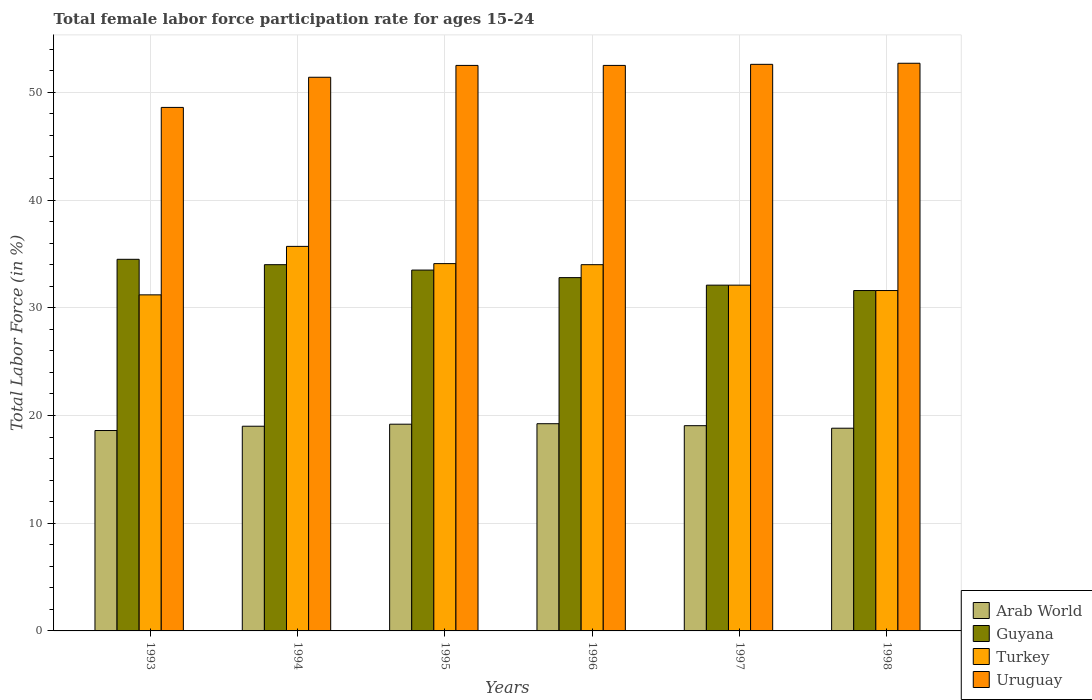Are the number of bars on each tick of the X-axis equal?
Provide a short and direct response. Yes. How many bars are there on the 2nd tick from the right?
Your response must be concise. 4. In how many cases, is the number of bars for a given year not equal to the number of legend labels?
Your response must be concise. 0. What is the female labor force participation rate in Uruguay in 1995?
Your answer should be compact. 52.5. Across all years, what is the maximum female labor force participation rate in Guyana?
Provide a succinct answer. 34.5. Across all years, what is the minimum female labor force participation rate in Arab World?
Keep it short and to the point. 18.6. In which year was the female labor force participation rate in Turkey maximum?
Give a very brief answer. 1994. What is the total female labor force participation rate in Arab World in the graph?
Ensure brevity in your answer.  113.91. What is the difference between the female labor force participation rate in Turkey in 1994 and that in 1998?
Ensure brevity in your answer.  4.1. What is the difference between the female labor force participation rate in Arab World in 1998 and the female labor force participation rate in Guyana in 1996?
Offer a terse response. -13.98. What is the average female labor force participation rate in Uruguay per year?
Your answer should be very brief. 51.72. In the year 1998, what is the difference between the female labor force participation rate in Arab World and female labor force participation rate in Turkey?
Offer a terse response. -12.78. What is the ratio of the female labor force participation rate in Guyana in 1995 to that in 1996?
Provide a succinct answer. 1.02. Is the difference between the female labor force participation rate in Arab World in 1993 and 1995 greater than the difference between the female labor force participation rate in Turkey in 1993 and 1995?
Your answer should be very brief. Yes. What is the difference between the highest and the second highest female labor force participation rate in Arab World?
Provide a short and direct response. 0.05. What is the difference between the highest and the lowest female labor force participation rate in Guyana?
Ensure brevity in your answer.  2.9. In how many years, is the female labor force participation rate in Uruguay greater than the average female labor force participation rate in Uruguay taken over all years?
Your response must be concise. 4. Is it the case that in every year, the sum of the female labor force participation rate in Turkey and female labor force participation rate in Uruguay is greater than the sum of female labor force participation rate in Guyana and female labor force participation rate in Arab World?
Provide a succinct answer. Yes. What does the 3rd bar from the left in 1995 represents?
Your response must be concise. Turkey. What does the 4th bar from the right in 1997 represents?
Your answer should be very brief. Arab World. What is the difference between two consecutive major ticks on the Y-axis?
Give a very brief answer. 10. Does the graph contain any zero values?
Ensure brevity in your answer.  No. Does the graph contain grids?
Provide a succinct answer. Yes. Where does the legend appear in the graph?
Ensure brevity in your answer.  Bottom right. How many legend labels are there?
Make the answer very short. 4. How are the legend labels stacked?
Give a very brief answer. Vertical. What is the title of the graph?
Keep it short and to the point. Total female labor force participation rate for ages 15-24. Does "Sudan" appear as one of the legend labels in the graph?
Ensure brevity in your answer.  No. What is the label or title of the X-axis?
Provide a short and direct response. Years. What is the label or title of the Y-axis?
Your answer should be compact. Total Labor Force (in %). What is the Total Labor Force (in %) in Arab World in 1993?
Your answer should be very brief. 18.6. What is the Total Labor Force (in %) of Guyana in 1993?
Make the answer very short. 34.5. What is the Total Labor Force (in %) of Turkey in 1993?
Give a very brief answer. 31.2. What is the Total Labor Force (in %) of Uruguay in 1993?
Your answer should be very brief. 48.6. What is the Total Labor Force (in %) in Arab World in 1994?
Your response must be concise. 19. What is the Total Labor Force (in %) of Turkey in 1994?
Your response must be concise. 35.7. What is the Total Labor Force (in %) in Uruguay in 1994?
Provide a short and direct response. 51.4. What is the Total Labor Force (in %) in Arab World in 1995?
Your answer should be compact. 19.19. What is the Total Labor Force (in %) of Guyana in 1995?
Provide a succinct answer. 33.5. What is the Total Labor Force (in %) in Turkey in 1995?
Offer a terse response. 34.1. What is the Total Labor Force (in %) of Uruguay in 1995?
Make the answer very short. 52.5. What is the Total Labor Force (in %) of Arab World in 1996?
Make the answer very short. 19.24. What is the Total Labor Force (in %) in Guyana in 1996?
Ensure brevity in your answer.  32.8. What is the Total Labor Force (in %) of Uruguay in 1996?
Your answer should be very brief. 52.5. What is the Total Labor Force (in %) of Arab World in 1997?
Make the answer very short. 19.05. What is the Total Labor Force (in %) of Guyana in 1997?
Give a very brief answer. 32.1. What is the Total Labor Force (in %) in Turkey in 1997?
Provide a succinct answer. 32.1. What is the Total Labor Force (in %) in Uruguay in 1997?
Your response must be concise. 52.6. What is the Total Labor Force (in %) in Arab World in 1998?
Provide a succinct answer. 18.82. What is the Total Labor Force (in %) of Guyana in 1998?
Give a very brief answer. 31.6. What is the Total Labor Force (in %) in Turkey in 1998?
Offer a very short reply. 31.6. What is the Total Labor Force (in %) of Uruguay in 1998?
Offer a very short reply. 52.7. Across all years, what is the maximum Total Labor Force (in %) of Arab World?
Your response must be concise. 19.24. Across all years, what is the maximum Total Labor Force (in %) in Guyana?
Your response must be concise. 34.5. Across all years, what is the maximum Total Labor Force (in %) in Turkey?
Keep it short and to the point. 35.7. Across all years, what is the maximum Total Labor Force (in %) in Uruguay?
Offer a very short reply. 52.7. Across all years, what is the minimum Total Labor Force (in %) in Arab World?
Make the answer very short. 18.6. Across all years, what is the minimum Total Labor Force (in %) of Guyana?
Keep it short and to the point. 31.6. Across all years, what is the minimum Total Labor Force (in %) of Turkey?
Your response must be concise. 31.2. Across all years, what is the minimum Total Labor Force (in %) in Uruguay?
Provide a short and direct response. 48.6. What is the total Total Labor Force (in %) in Arab World in the graph?
Make the answer very short. 113.91. What is the total Total Labor Force (in %) in Guyana in the graph?
Provide a short and direct response. 198.5. What is the total Total Labor Force (in %) in Turkey in the graph?
Give a very brief answer. 198.7. What is the total Total Labor Force (in %) in Uruguay in the graph?
Your response must be concise. 310.3. What is the difference between the Total Labor Force (in %) in Arab World in 1993 and that in 1994?
Offer a terse response. -0.4. What is the difference between the Total Labor Force (in %) in Uruguay in 1993 and that in 1994?
Keep it short and to the point. -2.8. What is the difference between the Total Labor Force (in %) of Arab World in 1993 and that in 1995?
Offer a very short reply. -0.59. What is the difference between the Total Labor Force (in %) in Guyana in 1993 and that in 1995?
Provide a succinct answer. 1. What is the difference between the Total Labor Force (in %) of Turkey in 1993 and that in 1995?
Make the answer very short. -2.9. What is the difference between the Total Labor Force (in %) of Arab World in 1993 and that in 1996?
Provide a short and direct response. -0.63. What is the difference between the Total Labor Force (in %) of Turkey in 1993 and that in 1996?
Ensure brevity in your answer.  -2.8. What is the difference between the Total Labor Force (in %) in Uruguay in 1993 and that in 1996?
Give a very brief answer. -3.9. What is the difference between the Total Labor Force (in %) of Arab World in 1993 and that in 1997?
Provide a short and direct response. -0.45. What is the difference between the Total Labor Force (in %) of Guyana in 1993 and that in 1997?
Make the answer very short. 2.4. What is the difference between the Total Labor Force (in %) in Uruguay in 1993 and that in 1997?
Offer a terse response. -4. What is the difference between the Total Labor Force (in %) in Arab World in 1993 and that in 1998?
Ensure brevity in your answer.  -0.22. What is the difference between the Total Labor Force (in %) of Guyana in 1993 and that in 1998?
Provide a short and direct response. 2.9. What is the difference between the Total Labor Force (in %) in Uruguay in 1993 and that in 1998?
Make the answer very short. -4.1. What is the difference between the Total Labor Force (in %) of Arab World in 1994 and that in 1995?
Offer a terse response. -0.19. What is the difference between the Total Labor Force (in %) in Uruguay in 1994 and that in 1995?
Offer a terse response. -1.1. What is the difference between the Total Labor Force (in %) in Arab World in 1994 and that in 1996?
Make the answer very short. -0.23. What is the difference between the Total Labor Force (in %) in Guyana in 1994 and that in 1996?
Keep it short and to the point. 1.2. What is the difference between the Total Labor Force (in %) in Turkey in 1994 and that in 1996?
Provide a succinct answer. 1.7. What is the difference between the Total Labor Force (in %) of Uruguay in 1994 and that in 1996?
Provide a short and direct response. -1.1. What is the difference between the Total Labor Force (in %) of Arab World in 1994 and that in 1997?
Give a very brief answer. -0.05. What is the difference between the Total Labor Force (in %) of Turkey in 1994 and that in 1997?
Your answer should be compact. 3.6. What is the difference between the Total Labor Force (in %) in Uruguay in 1994 and that in 1997?
Offer a very short reply. -1.2. What is the difference between the Total Labor Force (in %) of Arab World in 1994 and that in 1998?
Give a very brief answer. 0.18. What is the difference between the Total Labor Force (in %) in Guyana in 1994 and that in 1998?
Ensure brevity in your answer.  2.4. What is the difference between the Total Labor Force (in %) in Turkey in 1994 and that in 1998?
Your response must be concise. 4.1. What is the difference between the Total Labor Force (in %) in Arab World in 1995 and that in 1996?
Offer a terse response. -0.04. What is the difference between the Total Labor Force (in %) in Arab World in 1995 and that in 1997?
Give a very brief answer. 0.14. What is the difference between the Total Labor Force (in %) of Guyana in 1995 and that in 1997?
Your answer should be compact. 1.4. What is the difference between the Total Labor Force (in %) in Turkey in 1995 and that in 1997?
Your response must be concise. 2. What is the difference between the Total Labor Force (in %) of Uruguay in 1995 and that in 1997?
Your answer should be very brief. -0.1. What is the difference between the Total Labor Force (in %) of Arab World in 1995 and that in 1998?
Give a very brief answer. 0.37. What is the difference between the Total Labor Force (in %) of Arab World in 1996 and that in 1997?
Provide a short and direct response. 0.18. What is the difference between the Total Labor Force (in %) in Turkey in 1996 and that in 1997?
Your answer should be compact. 1.9. What is the difference between the Total Labor Force (in %) of Uruguay in 1996 and that in 1997?
Give a very brief answer. -0.1. What is the difference between the Total Labor Force (in %) of Arab World in 1996 and that in 1998?
Keep it short and to the point. 0.42. What is the difference between the Total Labor Force (in %) in Turkey in 1996 and that in 1998?
Offer a very short reply. 2.4. What is the difference between the Total Labor Force (in %) of Arab World in 1997 and that in 1998?
Your answer should be compact. 0.23. What is the difference between the Total Labor Force (in %) of Guyana in 1997 and that in 1998?
Keep it short and to the point. 0.5. What is the difference between the Total Labor Force (in %) of Turkey in 1997 and that in 1998?
Keep it short and to the point. 0.5. What is the difference between the Total Labor Force (in %) in Uruguay in 1997 and that in 1998?
Give a very brief answer. -0.1. What is the difference between the Total Labor Force (in %) of Arab World in 1993 and the Total Labor Force (in %) of Guyana in 1994?
Give a very brief answer. -15.4. What is the difference between the Total Labor Force (in %) in Arab World in 1993 and the Total Labor Force (in %) in Turkey in 1994?
Keep it short and to the point. -17.1. What is the difference between the Total Labor Force (in %) in Arab World in 1993 and the Total Labor Force (in %) in Uruguay in 1994?
Your response must be concise. -32.8. What is the difference between the Total Labor Force (in %) of Guyana in 1993 and the Total Labor Force (in %) of Turkey in 1994?
Provide a short and direct response. -1.2. What is the difference between the Total Labor Force (in %) in Guyana in 1993 and the Total Labor Force (in %) in Uruguay in 1994?
Ensure brevity in your answer.  -16.9. What is the difference between the Total Labor Force (in %) of Turkey in 1993 and the Total Labor Force (in %) of Uruguay in 1994?
Your answer should be compact. -20.2. What is the difference between the Total Labor Force (in %) in Arab World in 1993 and the Total Labor Force (in %) in Guyana in 1995?
Your answer should be compact. -14.9. What is the difference between the Total Labor Force (in %) of Arab World in 1993 and the Total Labor Force (in %) of Turkey in 1995?
Offer a terse response. -15.5. What is the difference between the Total Labor Force (in %) in Arab World in 1993 and the Total Labor Force (in %) in Uruguay in 1995?
Provide a short and direct response. -33.9. What is the difference between the Total Labor Force (in %) of Guyana in 1993 and the Total Labor Force (in %) of Turkey in 1995?
Keep it short and to the point. 0.4. What is the difference between the Total Labor Force (in %) in Guyana in 1993 and the Total Labor Force (in %) in Uruguay in 1995?
Make the answer very short. -18. What is the difference between the Total Labor Force (in %) of Turkey in 1993 and the Total Labor Force (in %) of Uruguay in 1995?
Make the answer very short. -21.3. What is the difference between the Total Labor Force (in %) of Arab World in 1993 and the Total Labor Force (in %) of Guyana in 1996?
Keep it short and to the point. -14.2. What is the difference between the Total Labor Force (in %) in Arab World in 1993 and the Total Labor Force (in %) in Turkey in 1996?
Make the answer very short. -15.4. What is the difference between the Total Labor Force (in %) in Arab World in 1993 and the Total Labor Force (in %) in Uruguay in 1996?
Provide a succinct answer. -33.9. What is the difference between the Total Labor Force (in %) in Guyana in 1993 and the Total Labor Force (in %) in Turkey in 1996?
Your answer should be very brief. 0.5. What is the difference between the Total Labor Force (in %) of Turkey in 1993 and the Total Labor Force (in %) of Uruguay in 1996?
Your answer should be very brief. -21.3. What is the difference between the Total Labor Force (in %) of Arab World in 1993 and the Total Labor Force (in %) of Guyana in 1997?
Provide a short and direct response. -13.5. What is the difference between the Total Labor Force (in %) of Arab World in 1993 and the Total Labor Force (in %) of Turkey in 1997?
Your answer should be very brief. -13.5. What is the difference between the Total Labor Force (in %) in Arab World in 1993 and the Total Labor Force (in %) in Uruguay in 1997?
Make the answer very short. -34. What is the difference between the Total Labor Force (in %) of Guyana in 1993 and the Total Labor Force (in %) of Uruguay in 1997?
Your answer should be compact. -18.1. What is the difference between the Total Labor Force (in %) in Turkey in 1993 and the Total Labor Force (in %) in Uruguay in 1997?
Provide a succinct answer. -21.4. What is the difference between the Total Labor Force (in %) of Arab World in 1993 and the Total Labor Force (in %) of Guyana in 1998?
Make the answer very short. -13. What is the difference between the Total Labor Force (in %) in Arab World in 1993 and the Total Labor Force (in %) in Turkey in 1998?
Offer a terse response. -13. What is the difference between the Total Labor Force (in %) in Arab World in 1993 and the Total Labor Force (in %) in Uruguay in 1998?
Provide a short and direct response. -34.1. What is the difference between the Total Labor Force (in %) of Guyana in 1993 and the Total Labor Force (in %) of Turkey in 1998?
Offer a terse response. 2.9. What is the difference between the Total Labor Force (in %) in Guyana in 1993 and the Total Labor Force (in %) in Uruguay in 1998?
Provide a short and direct response. -18.2. What is the difference between the Total Labor Force (in %) in Turkey in 1993 and the Total Labor Force (in %) in Uruguay in 1998?
Ensure brevity in your answer.  -21.5. What is the difference between the Total Labor Force (in %) of Arab World in 1994 and the Total Labor Force (in %) of Guyana in 1995?
Your response must be concise. -14.5. What is the difference between the Total Labor Force (in %) in Arab World in 1994 and the Total Labor Force (in %) in Turkey in 1995?
Your answer should be compact. -15.1. What is the difference between the Total Labor Force (in %) in Arab World in 1994 and the Total Labor Force (in %) in Uruguay in 1995?
Offer a terse response. -33.5. What is the difference between the Total Labor Force (in %) of Guyana in 1994 and the Total Labor Force (in %) of Turkey in 1995?
Keep it short and to the point. -0.1. What is the difference between the Total Labor Force (in %) of Guyana in 1994 and the Total Labor Force (in %) of Uruguay in 1995?
Offer a very short reply. -18.5. What is the difference between the Total Labor Force (in %) of Turkey in 1994 and the Total Labor Force (in %) of Uruguay in 1995?
Offer a terse response. -16.8. What is the difference between the Total Labor Force (in %) in Arab World in 1994 and the Total Labor Force (in %) in Guyana in 1996?
Give a very brief answer. -13.8. What is the difference between the Total Labor Force (in %) of Arab World in 1994 and the Total Labor Force (in %) of Turkey in 1996?
Offer a terse response. -15. What is the difference between the Total Labor Force (in %) in Arab World in 1994 and the Total Labor Force (in %) in Uruguay in 1996?
Provide a succinct answer. -33.5. What is the difference between the Total Labor Force (in %) in Guyana in 1994 and the Total Labor Force (in %) in Uruguay in 1996?
Your response must be concise. -18.5. What is the difference between the Total Labor Force (in %) in Turkey in 1994 and the Total Labor Force (in %) in Uruguay in 1996?
Offer a terse response. -16.8. What is the difference between the Total Labor Force (in %) of Arab World in 1994 and the Total Labor Force (in %) of Guyana in 1997?
Your response must be concise. -13.1. What is the difference between the Total Labor Force (in %) of Arab World in 1994 and the Total Labor Force (in %) of Turkey in 1997?
Keep it short and to the point. -13.1. What is the difference between the Total Labor Force (in %) in Arab World in 1994 and the Total Labor Force (in %) in Uruguay in 1997?
Offer a terse response. -33.6. What is the difference between the Total Labor Force (in %) of Guyana in 1994 and the Total Labor Force (in %) of Uruguay in 1997?
Keep it short and to the point. -18.6. What is the difference between the Total Labor Force (in %) in Turkey in 1994 and the Total Labor Force (in %) in Uruguay in 1997?
Give a very brief answer. -16.9. What is the difference between the Total Labor Force (in %) of Arab World in 1994 and the Total Labor Force (in %) of Guyana in 1998?
Offer a very short reply. -12.6. What is the difference between the Total Labor Force (in %) of Arab World in 1994 and the Total Labor Force (in %) of Turkey in 1998?
Your answer should be compact. -12.6. What is the difference between the Total Labor Force (in %) in Arab World in 1994 and the Total Labor Force (in %) in Uruguay in 1998?
Your answer should be very brief. -33.7. What is the difference between the Total Labor Force (in %) of Guyana in 1994 and the Total Labor Force (in %) of Turkey in 1998?
Your answer should be very brief. 2.4. What is the difference between the Total Labor Force (in %) in Guyana in 1994 and the Total Labor Force (in %) in Uruguay in 1998?
Provide a short and direct response. -18.7. What is the difference between the Total Labor Force (in %) in Turkey in 1994 and the Total Labor Force (in %) in Uruguay in 1998?
Your response must be concise. -17. What is the difference between the Total Labor Force (in %) of Arab World in 1995 and the Total Labor Force (in %) of Guyana in 1996?
Ensure brevity in your answer.  -13.61. What is the difference between the Total Labor Force (in %) in Arab World in 1995 and the Total Labor Force (in %) in Turkey in 1996?
Your answer should be compact. -14.81. What is the difference between the Total Labor Force (in %) of Arab World in 1995 and the Total Labor Force (in %) of Uruguay in 1996?
Your answer should be compact. -33.31. What is the difference between the Total Labor Force (in %) of Guyana in 1995 and the Total Labor Force (in %) of Turkey in 1996?
Give a very brief answer. -0.5. What is the difference between the Total Labor Force (in %) of Turkey in 1995 and the Total Labor Force (in %) of Uruguay in 1996?
Your response must be concise. -18.4. What is the difference between the Total Labor Force (in %) of Arab World in 1995 and the Total Labor Force (in %) of Guyana in 1997?
Give a very brief answer. -12.91. What is the difference between the Total Labor Force (in %) of Arab World in 1995 and the Total Labor Force (in %) of Turkey in 1997?
Offer a very short reply. -12.91. What is the difference between the Total Labor Force (in %) of Arab World in 1995 and the Total Labor Force (in %) of Uruguay in 1997?
Provide a succinct answer. -33.41. What is the difference between the Total Labor Force (in %) in Guyana in 1995 and the Total Labor Force (in %) in Uruguay in 1997?
Make the answer very short. -19.1. What is the difference between the Total Labor Force (in %) in Turkey in 1995 and the Total Labor Force (in %) in Uruguay in 1997?
Your answer should be compact. -18.5. What is the difference between the Total Labor Force (in %) in Arab World in 1995 and the Total Labor Force (in %) in Guyana in 1998?
Your response must be concise. -12.41. What is the difference between the Total Labor Force (in %) in Arab World in 1995 and the Total Labor Force (in %) in Turkey in 1998?
Your answer should be very brief. -12.41. What is the difference between the Total Labor Force (in %) in Arab World in 1995 and the Total Labor Force (in %) in Uruguay in 1998?
Keep it short and to the point. -33.51. What is the difference between the Total Labor Force (in %) of Guyana in 1995 and the Total Labor Force (in %) of Turkey in 1998?
Make the answer very short. 1.9. What is the difference between the Total Labor Force (in %) of Guyana in 1995 and the Total Labor Force (in %) of Uruguay in 1998?
Provide a short and direct response. -19.2. What is the difference between the Total Labor Force (in %) of Turkey in 1995 and the Total Labor Force (in %) of Uruguay in 1998?
Make the answer very short. -18.6. What is the difference between the Total Labor Force (in %) of Arab World in 1996 and the Total Labor Force (in %) of Guyana in 1997?
Your response must be concise. -12.86. What is the difference between the Total Labor Force (in %) in Arab World in 1996 and the Total Labor Force (in %) in Turkey in 1997?
Ensure brevity in your answer.  -12.86. What is the difference between the Total Labor Force (in %) in Arab World in 1996 and the Total Labor Force (in %) in Uruguay in 1997?
Provide a short and direct response. -33.36. What is the difference between the Total Labor Force (in %) of Guyana in 1996 and the Total Labor Force (in %) of Uruguay in 1997?
Offer a very short reply. -19.8. What is the difference between the Total Labor Force (in %) in Turkey in 1996 and the Total Labor Force (in %) in Uruguay in 1997?
Your response must be concise. -18.6. What is the difference between the Total Labor Force (in %) in Arab World in 1996 and the Total Labor Force (in %) in Guyana in 1998?
Offer a terse response. -12.36. What is the difference between the Total Labor Force (in %) in Arab World in 1996 and the Total Labor Force (in %) in Turkey in 1998?
Keep it short and to the point. -12.36. What is the difference between the Total Labor Force (in %) of Arab World in 1996 and the Total Labor Force (in %) of Uruguay in 1998?
Your answer should be compact. -33.46. What is the difference between the Total Labor Force (in %) of Guyana in 1996 and the Total Labor Force (in %) of Uruguay in 1998?
Ensure brevity in your answer.  -19.9. What is the difference between the Total Labor Force (in %) in Turkey in 1996 and the Total Labor Force (in %) in Uruguay in 1998?
Your answer should be very brief. -18.7. What is the difference between the Total Labor Force (in %) in Arab World in 1997 and the Total Labor Force (in %) in Guyana in 1998?
Offer a very short reply. -12.55. What is the difference between the Total Labor Force (in %) in Arab World in 1997 and the Total Labor Force (in %) in Turkey in 1998?
Your response must be concise. -12.55. What is the difference between the Total Labor Force (in %) of Arab World in 1997 and the Total Labor Force (in %) of Uruguay in 1998?
Provide a succinct answer. -33.65. What is the difference between the Total Labor Force (in %) of Guyana in 1997 and the Total Labor Force (in %) of Turkey in 1998?
Offer a terse response. 0.5. What is the difference between the Total Labor Force (in %) in Guyana in 1997 and the Total Labor Force (in %) in Uruguay in 1998?
Offer a very short reply. -20.6. What is the difference between the Total Labor Force (in %) in Turkey in 1997 and the Total Labor Force (in %) in Uruguay in 1998?
Your answer should be compact. -20.6. What is the average Total Labor Force (in %) in Arab World per year?
Offer a terse response. 18.98. What is the average Total Labor Force (in %) in Guyana per year?
Your answer should be compact. 33.08. What is the average Total Labor Force (in %) of Turkey per year?
Your answer should be compact. 33.12. What is the average Total Labor Force (in %) in Uruguay per year?
Ensure brevity in your answer.  51.72. In the year 1993, what is the difference between the Total Labor Force (in %) of Arab World and Total Labor Force (in %) of Guyana?
Offer a terse response. -15.9. In the year 1993, what is the difference between the Total Labor Force (in %) of Arab World and Total Labor Force (in %) of Turkey?
Give a very brief answer. -12.6. In the year 1993, what is the difference between the Total Labor Force (in %) of Arab World and Total Labor Force (in %) of Uruguay?
Offer a very short reply. -30. In the year 1993, what is the difference between the Total Labor Force (in %) in Guyana and Total Labor Force (in %) in Uruguay?
Provide a succinct answer. -14.1. In the year 1993, what is the difference between the Total Labor Force (in %) in Turkey and Total Labor Force (in %) in Uruguay?
Your answer should be compact. -17.4. In the year 1994, what is the difference between the Total Labor Force (in %) in Arab World and Total Labor Force (in %) in Guyana?
Make the answer very short. -15. In the year 1994, what is the difference between the Total Labor Force (in %) in Arab World and Total Labor Force (in %) in Turkey?
Your answer should be compact. -16.7. In the year 1994, what is the difference between the Total Labor Force (in %) of Arab World and Total Labor Force (in %) of Uruguay?
Make the answer very short. -32.4. In the year 1994, what is the difference between the Total Labor Force (in %) of Guyana and Total Labor Force (in %) of Uruguay?
Keep it short and to the point. -17.4. In the year 1994, what is the difference between the Total Labor Force (in %) of Turkey and Total Labor Force (in %) of Uruguay?
Make the answer very short. -15.7. In the year 1995, what is the difference between the Total Labor Force (in %) in Arab World and Total Labor Force (in %) in Guyana?
Your response must be concise. -14.31. In the year 1995, what is the difference between the Total Labor Force (in %) of Arab World and Total Labor Force (in %) of Turkey?
Make the answer very short. -14.91. In the year 1995, what is the difference between the Total Labor Force (in %) in Arab World and Total Labor Force (in %) in Uruguay?
Your response must be concise. -33.31. In the year 1995, what is the difference between the Total Labor Force (in %) in Guyana and Total Labor Force (in %) in Turkey?
Your response must be concise. -0.6. In the year 1995, what is the difference between the Total Labor Force (in %) in Guyana and Total Labor Force (in %) in Uruguay?
Provide a short and direct response. -19. In the year 1995, what is the difference between the Total Labor Force (in %) in Turkey and Total Labor Force (in %) in Uruguay?
Give a very brief answer. -18.4. In the year 1996, what is the difference between the Total Labor Force (in %) in Arab World and Total Labor Force (in %) in Guyana?
Give a very brief answer. -13.56. In the year 1996, what is the difference between the Total Labor Force (in %) in Arab World and Total Labor Force (in %) in Turkey?
Your answer should be very brief. -14.76. In the year 1996, what is the difference between the Total Labor Force (in %) of Arab World and Total Labor Force (in %) of Uruguay?
Your response must be concise. -33.26. In the year 1996, what is the difference between the Total Labor Force (in %) of Guyana and Total Labor Force (in %) of Uruguay?
Make the answer very short. -19.7. In the year 1996, what is the difference between the Total Labor Force (in %) of Turkey and Total Labor Force (in %) of Uruguay?
Make the answer very short. -18.5. In the year 1997, what is the difference between the Total Labor Force (in %) of Arab World and Total Labor Force (in %) of Guyana?
Make the answer very short. -13.05. In the year 1997, what is the difference between the Total Labor Force (in %) of Arab World and Total Labor Force (in %) of Turkey?
Your response must be concise. -13.05. In the year 1997, what is the difference between the Total Labor Force (in %) in Arab World and Total Labor Force (in %) in Uruguay?
Make the answer very short. -33.55. In the year 1997, what is the difference between the Total Labor Force (in %) in Guyana and Total Labor Force (in %) in Uruguay?
Make the answer very short. -20.5. In the year 1997, what is the difference between the Total Labor Force (in %) in Turkey and Total Labor Force (in %) in Uruguay?
Give a very brief answer. -20.5. In the year 1998, what is the difference between the Total Labor Force (in %) in Arab World and Total Labor Force (in %) in Guyana?
Provide a short and direct response. -12.78. In the year 1998, what is the difference between the Total Labor Force (in %) of Arab World and Total Labor Force (in %) of Turkey?
Keep it short and to the point. -12.78. In the year 1998, what is the difference between the Total Labor Force (in %) of Arab World and Total Labor Force (in %) of Uruguay?
Offer a very short reply. -33.88. In the year 1998, what is the difference between the Total Labor Force (in %) in Guyana and Total Labor Force (in %) in Uruguay?
Make the answer very short. -21.1. In the year 1998, what is the difference between the Total Labor Force (in %) in Turkey and Total Labor Force (in %) in Uruguay?
Give a very brief answer. -21.1. What is the ratio of the Total Labor Force (in %) in Arab World in 1993 to that in 1994?
Provide a short and direct response. 0.98. What is the ratio of the Total Labor Force (in %) of Guyana in 1993 to that in 1994?
Provide a short and direct response. 1.01. What is the ratio of the Total Labor Force (in %) in Turkey in 1993 to that in 1994?
Offer a very short reply. 0.87. What is the ratio of the Total Labor Force (in %) of Uruguay in 1993 to that in 1994?
Offer a very short reply. 0.95. What is the ratio of the Total Labor Force (in %) of Arab World in 1993 to that in 1995?
Give a very brief answer. 0.97. What is the ratio of the Total Labor Force (in %) in Guyana in 1993 to that in 1995?
Give a very brief answer. 1.03. What is the ratio of the Total Labor Force (in %) of Turkey in 1993 to that in 1995?
Provide a short and direct response. 0.92. What is the ratio of the Total Labor Force (in %) of Uruguay in 1993 to that in 1995?
Give a very brief answer. 0.93. What is the ratio of the Total Labor Force (in %) of Arab World in 1993 to that in 1996?
Provide a succinct answer. 0.97. What is the ratio of the Total Labor Force (in %) in Guyana in 1993 to that in 1996?
Offer a very short reply. 1.05. What is the ratio of the Total Labor Force (in %) in Turkey in 1993 to that in 1996?
Keep it short and to the point. 0.92. What is the ratio of the Total Labor Force (in %) of Uruguay in 1993 to that in 1996?
Your response must be concise. 0.93. What is the ratio of the Total Labor Force (in %) in Arab World in 1993 to that in 1997?
Keep it short and to the point. 0.98. What is the ratio of the Total Labor Force (in %) in Guyana in 1993 to that in 1997?
Offer a terse response. 1.07. What is the ratio of the Total Labor Force (in %) in Uruguay in 1993 to that in 1997?
Make the answer very short. 0.92. What is the ratio of the Total Labor Force (in %) in Guyana in 1993 to that in 1998?
Offer a very short reply. 1.09. What is the ratio of the Total Labor Force (in %) in Turkey in 1993 to that in 1998?
Give a very brief answer. 0.99. What is the ratio of the Total Labor Force (in %) of Uruguay in 1993 to that in 1998?
Ensure brevity in your answer.  0.92. What is the ratio of the Total Labor Force (in %) of Guyana in 1994 to that in 1995?
Your answer should be compact. 1.01. What is the ratio of the Total Labor Force (in %) in Turkey in 1994 to that in 1995?
Your answer should be very brief. 1.05. What is the ratio of the Total Labor Force (in %) of Guyana in 1994 to that in 1996?
Keep it short and to the point. 1.04. What is the ratio of the Total Labor Force (in %) in Uruguay in 1994 to that in 1996?
Give a very brief answer. 0.98. What is the ratio of the Total Labor Force (in %) of Arab World in 1994 to that in 1997?
Your response must be concise. 1. What is the ratio of the Total Labor Force (in %) in Guyana in 1994 to that in 1997?
Ensure brevity in your answer.  1.06. What is the ratio of the Total Labor Force (in %) of Turkey in 1994 to that in 1997?
Give a very brief answer. 1.11. What is the ratio of the Total Labor Force (in %) of Uruguay in 1994 to that in 1997?
Offer a very short reply. 0.98. What is the ratio of the Total Labor Force (in %) of Arab World in 1994 to that in 1998?
Your answer should be compact. 1.01. What is the ratio of the Total Labor Force (in %) in Guyana in 1994 to that in 1998?
Keep it short and to the point. 1.08. What is the ratio of the Total Labor Force (in %) in Turkey in 1994 to that in 1998?
Provide a succinct answer. 1.13. What is the ratio of the Total Labor Force (in %) in Uruguay in 1994 to that in 1998?
Make the answer very short. 0.98. What is the ratio of the Total Labor Force (in %) of Guyana in 1995 to that in 1996?
Ensure brevity in your answer.  1.02. What is the ratio of the Total Labor Force (in %) in Uruguay in 1995 to that in 1996?
Ensure brevity in your answer.  1. What is the ratio of the Total Labor Force (in %) in Arab World in 1995 to that in 1997?
Keep it short and to the point. 1.01. What is the ratio of the Total Labor Force (in %) in Guyana in 1995 to that in 1997?
Your response must be concise. 1.04. What is the ratio of the Total Labor Force (in %) of Turkey in 1995 to that in 1997?
Your response must be concise. 1.06. What is the ratio of the Total Labor Force (in %) of Arab World in 1995 to that in 1998?
Offer a very short reply. 1.02. What is the ratio of the Total Labor Force (in %) in Guyana in 1995 to that in 1998?
Offer a terse response. 1.06. What is the ratio of the Total Labor Force (in %) of Turkey in 1995 to that in 1998?
Make the answer very short. 1.08. What is the ratio of the Total Labor Force (in %) of Arab World in 1996 to that in 1997?
Ensure brevity in your answer.  1.01. What is the ratio of the Total Labor Force (in %) in Guyana in 1996 to that in 1997?
Provide a short and direct response. 1.02. What is the ratio of the Total Labor Force (in %) in Turkey in 1996 to that in 1997?
Offer a terse response. 1.06. What is the ratio of the Total Labor Force (in %) in Arab World in 1996 to that in 1998?
Your answer should be compact. 1.02. What is the ratio of the Total Labor Force (in %) of Guyana in 1996 to that in 1998?
Provide a succinct answer. 1.04. What is the ratio of the Total Labor Force (in %) of Turkey in 1996 to that in 1998?
Offer a terse response. 1.08. What is the ratio of the Total Labor Force (in %) in Uruguay in 1996 to that in 1998?
Offer a very short reply. 1. What is the ratio of the Total Labor Force (in %) of Arab World in 1997 to that in 1998?
Ensure brevity in your answer.  1.01. What is the ratio of the Total Labor Force (in %) of Guyana in 1997 to that in 1998?
Offer a very short reply. 1.02. What is the ratio of the Total Labor Force (in %) of Turkey in 1997 to that in 1998?
Provide a succinct answer. 1.02. What is the difference between the highest and the second highest Total Labor Force (in %) in Arab World?
Ensure brevity in your answer.  0.04. What is the difference between the highest and the lowest Total Labor Force (in %) in Arab World?
Your answer should be compact. 0.63. What is the difference between the highest and the lowest Total Labor Force (in %) in Turkey?
Keep it short and to the point. 4.5. What is the difference between the highest and the lowest Total Labor Force (in %) of Uruguay?
Your answer should be very brief. 4.1. 